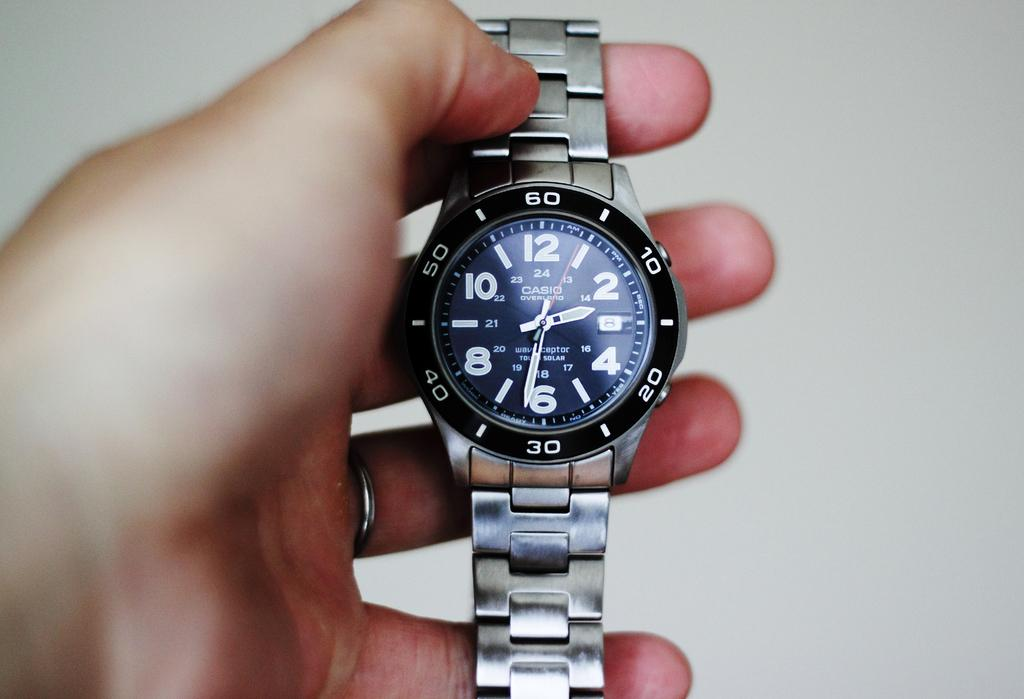<image>
Create a compact narrative representing the image presented. A person is holding a blue and silver, Casio men's wrist watch that reads the time as 2:31. 